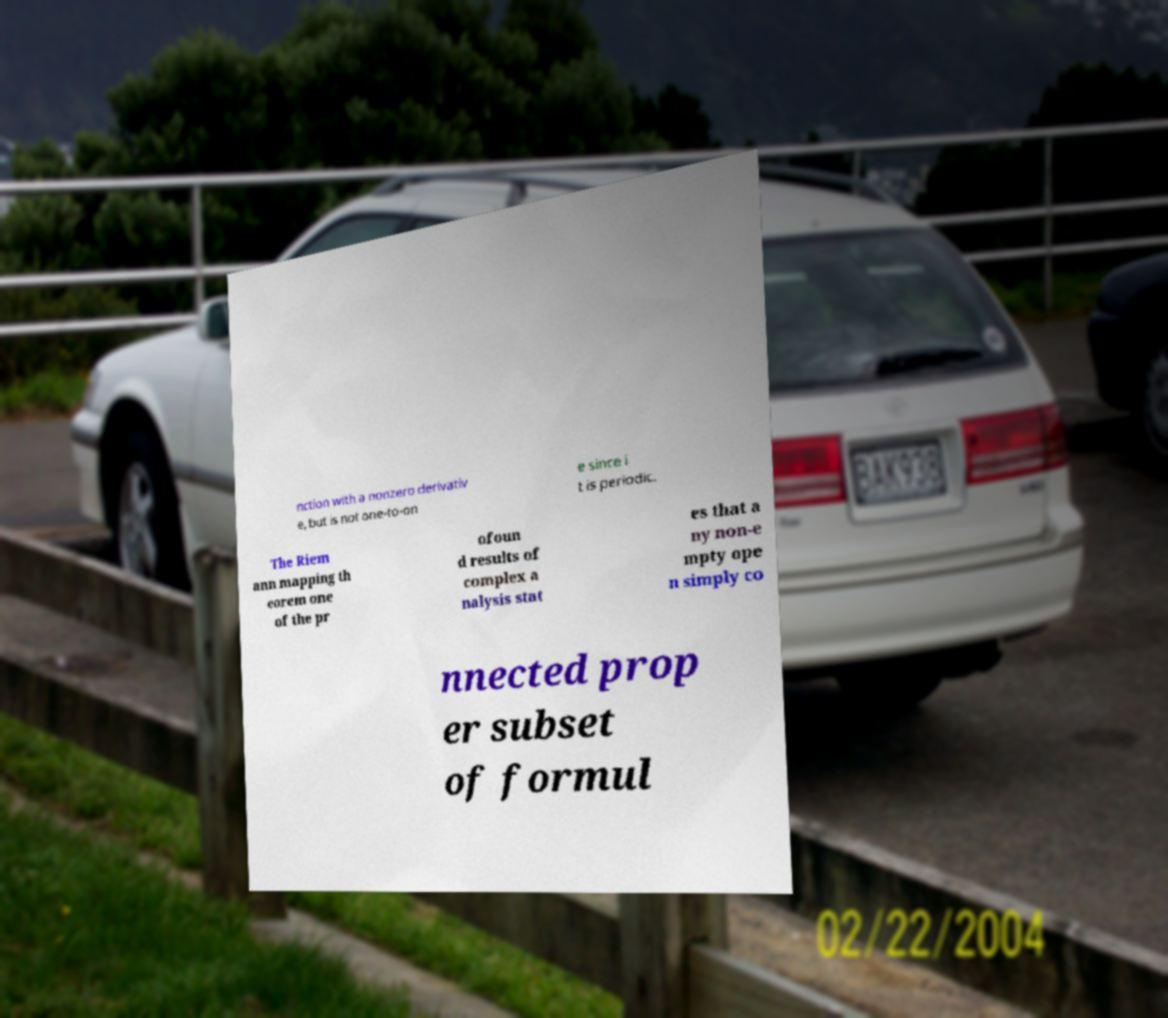Please read and relay the text visible in this image. What does it say? nction with a nonzero derivativ e, but is not one-to-on e since i t is periodic. The Riem ann mapping th eorem one of the pr ofoun d results of complex a nalysis stat es that a ny non-e mpty ope n simply co nnected prop er subset of formul 